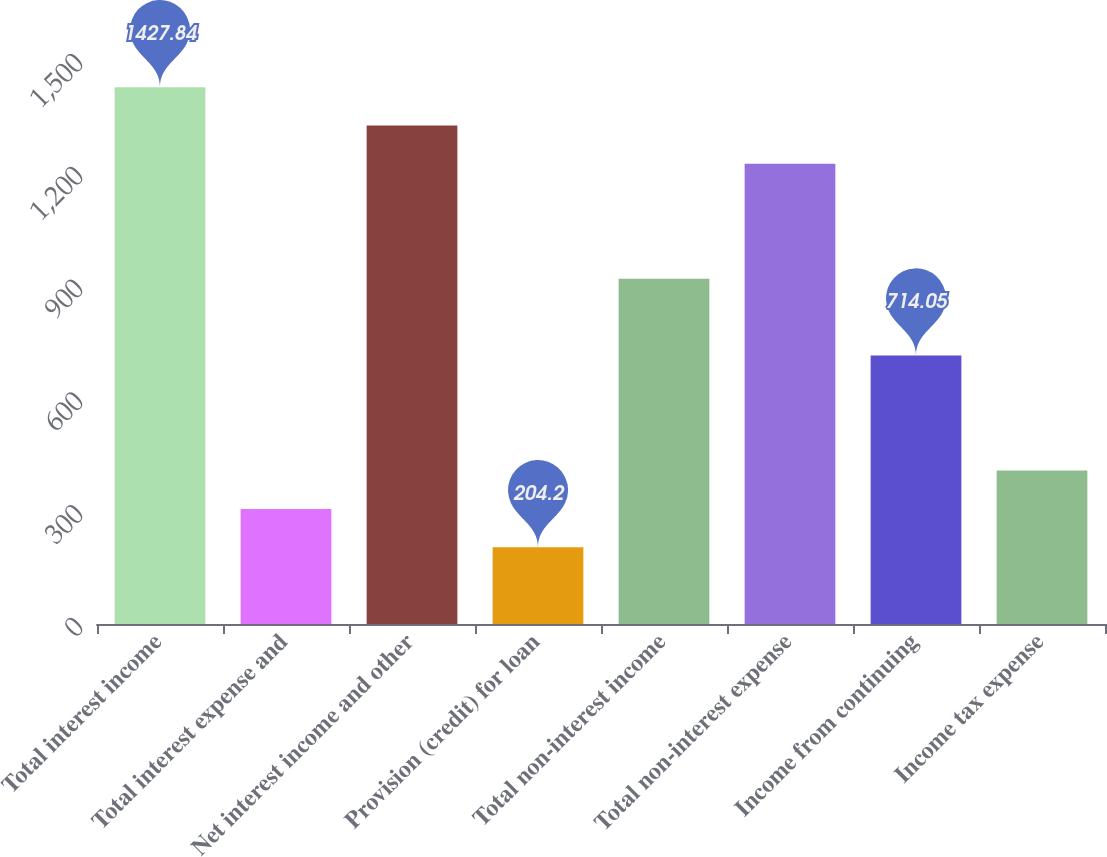<chart> <loc_0><loc_0><loc_500><loc_500><bar_chart><fcel>Total interest income<fcel>Total interest expense and<fcel>Net interest income and other<fcel>Provision (credit) for loan<fcel>Total non-interest income<fcel>Total non-interest expense<fcel>Income from continuing<fcel>Income tax expense<nl><fcel>1427.84<fcel>306.17<fcel>1325.87<fcel>204.2<fcel>917.99<fcel>1223.9<fcel>714.05<fcel>408.14<nl></chart> 